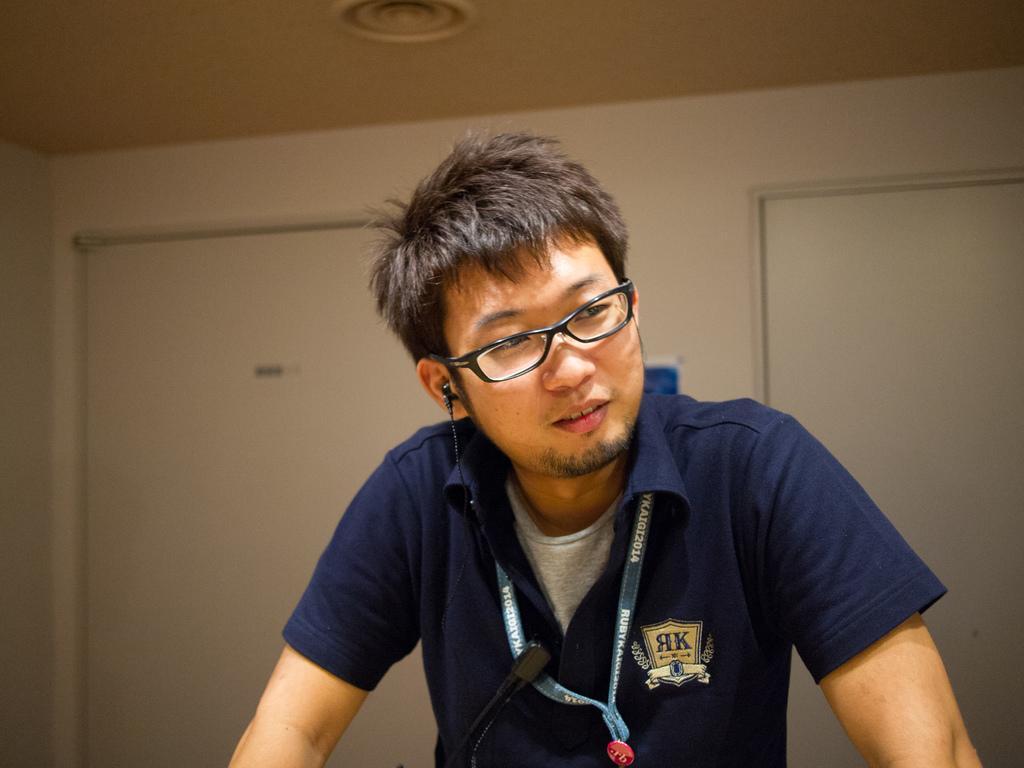Can you describe this image briefly? In this image there is a person. In front of him there is a mike. Behind him there is a wall. On top of the image there is a light. 